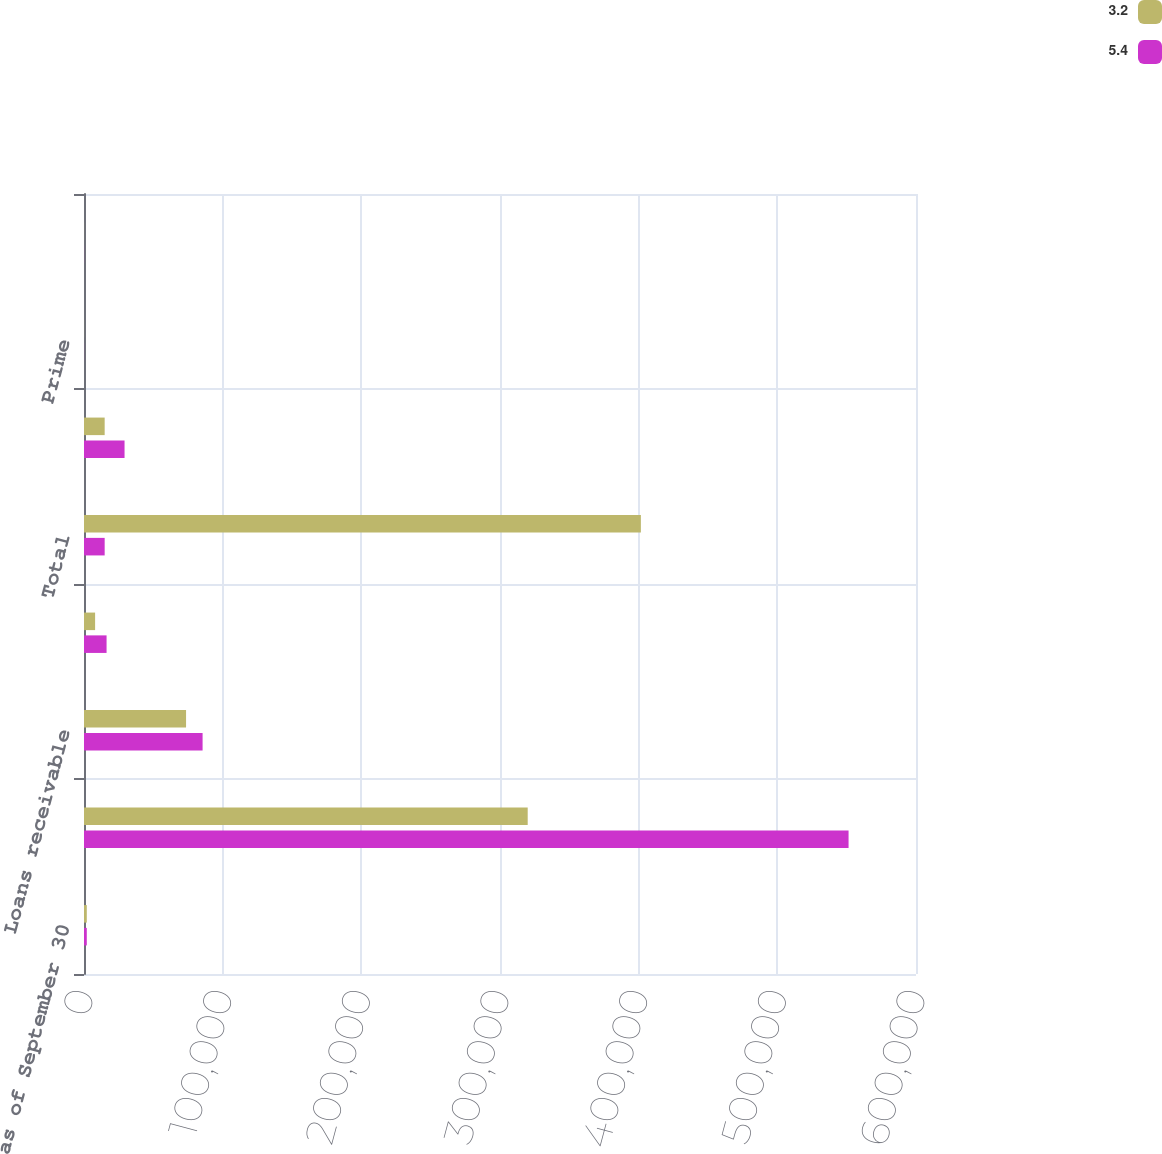Convert chart. <chart><loc_0><loc_0><loc_500><loc_500><stacked_bar_chart><ecel><fcel>as of September 30<fcel>Securitized loans<fcel>Loans receivable<fcel>Loans held for sale<fcel>Total<fcel>Principal amount of loans 30<fcel>Prime<fcel>Non-prime<nl><fcel>3.2<fcel>2010<fcel>319976<fcel>73602<fcel>8011<fcel>401589<fcel>14905<fcel>46.2<fcel>48.4<nl><fcel>5.4<fcel>2009<fcel>551369<fcel>85520<fcel>16274<fcel>14905<fcel>29238<fcel>47.4<fcel>49.4<nl></chart> 